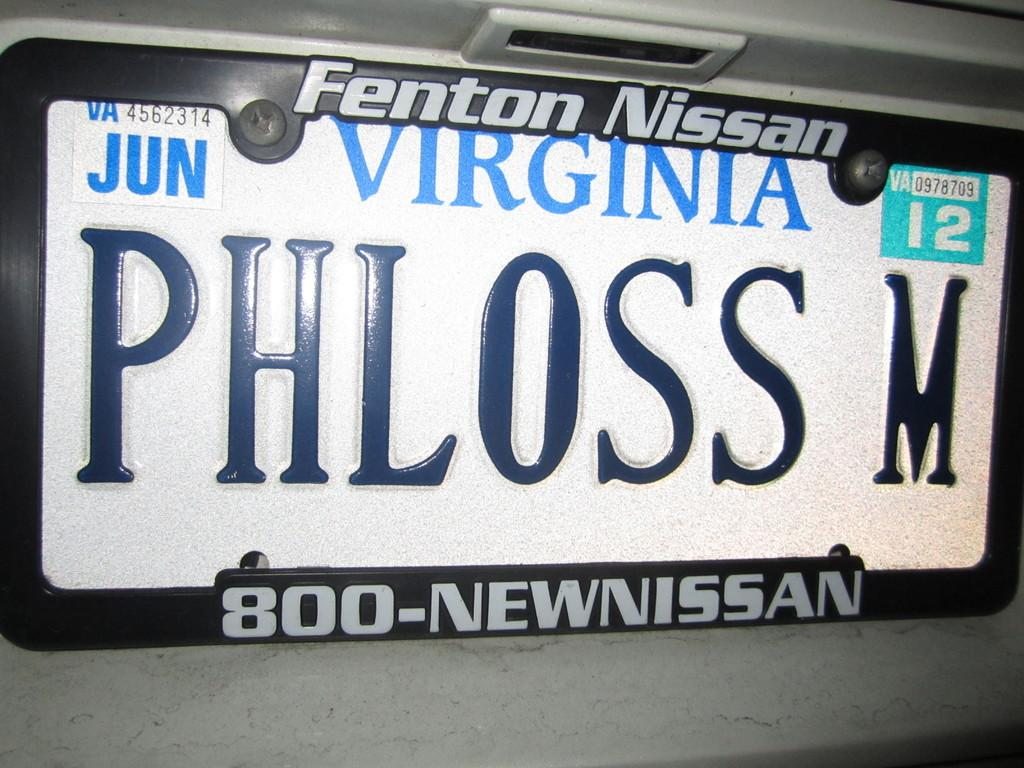<image>
Summarize the visual content of the image. A license plate from Virginia with the writing PHLOSS M on it. 